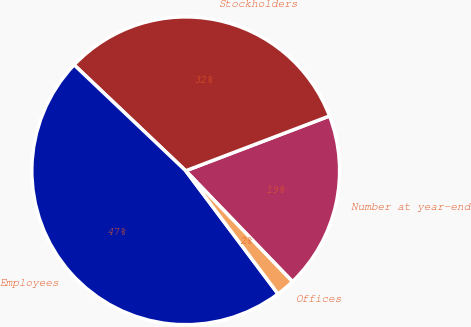Convert chart. <chart><loc_0><loc_0><loc_500><loc_500><pie_chart><fcel>Number at year-end<fcel>Stockholders<fcel>Employees<fcel>Offices<nl><fcel>18.6%<fcel>32.12%<fcel>47.33%<fcel>1.96%<nl></chart> 